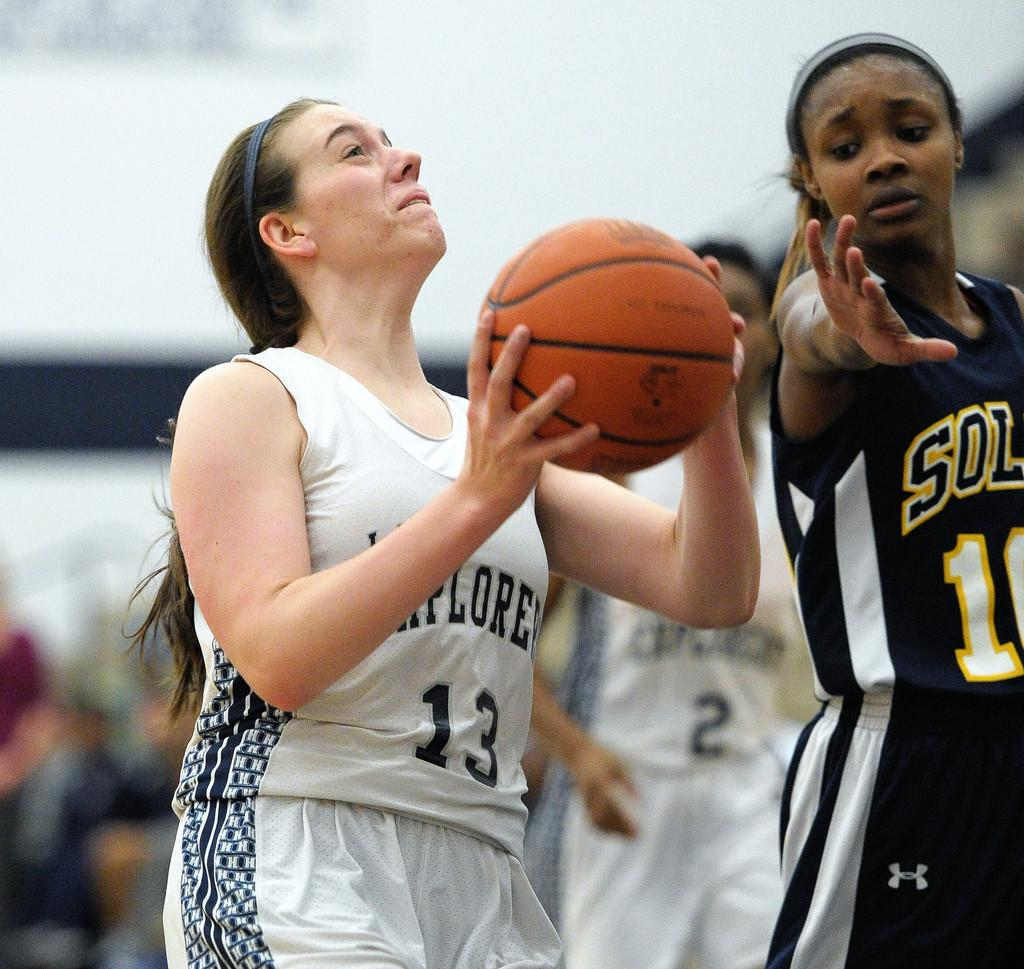<image>
Relay a brief, clear account of the picture shown. the number 13 is on the jersey of the player 